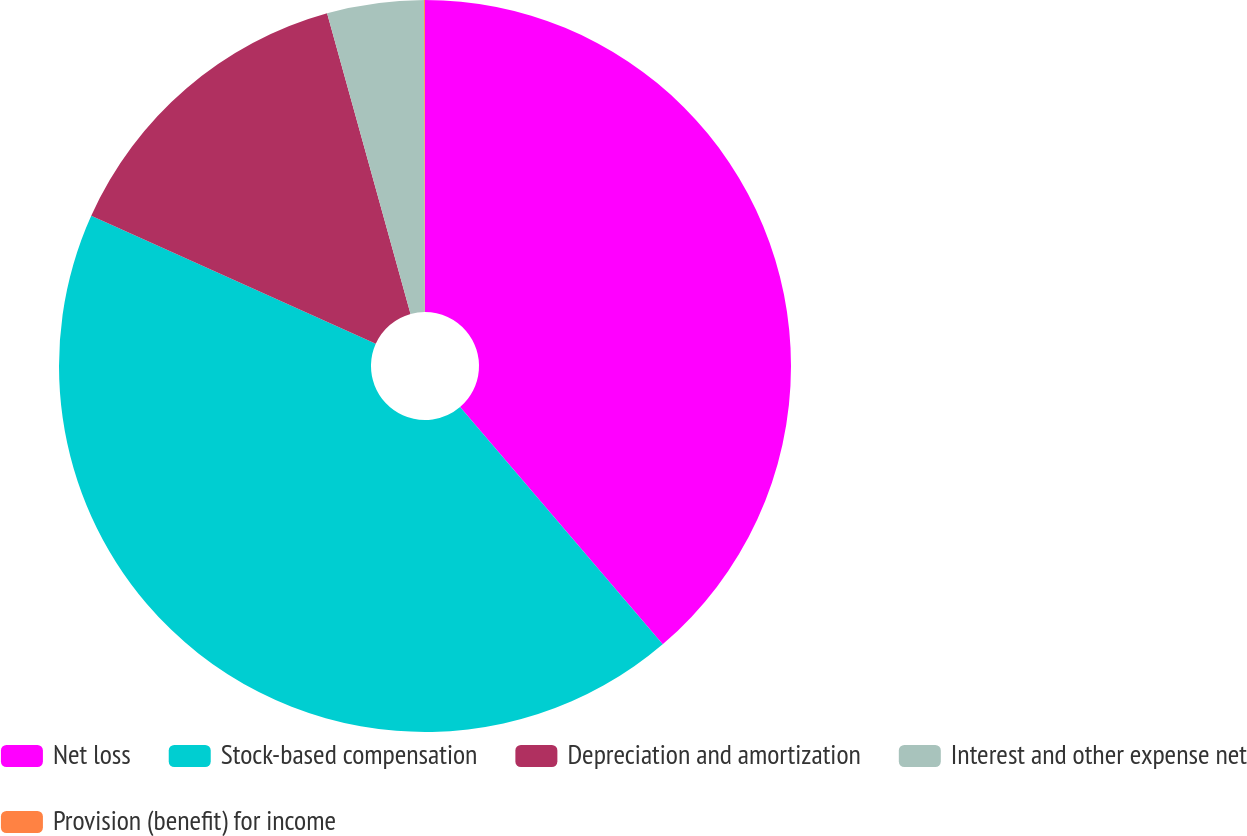Convert chart to OTSL. <chart><loc_0><loc_0><loc_500><loc_500><pie_chart><fcel>Net loss<fcel>Stock-based compensation<fcel>Depreciation and amortization<fcel>Interest and other expense net<fcel>Provision (benefit) for income<nl><fcel>38.75%<fcel>42.98%<fcel>13.96%<fcel>4.27%<fcel>0.04%<nl></chart> 